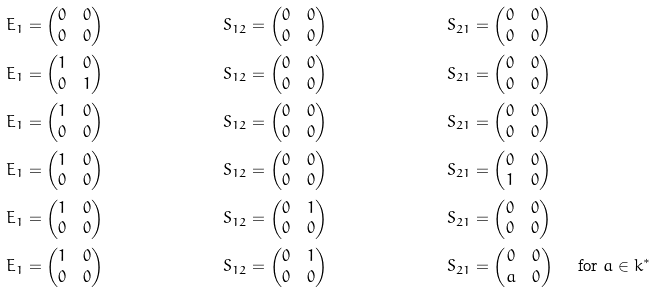<formula> <loc_0><loc_0><loc_500><loc_500>E _ { 1 } & = \left ( \begin{matrix} 0 & 0 \\ 0 & 0 \end{matrix} \right ) & S _ { 1 2 } & = \left ( \begin{matrix} 0 & 0 \\ 0 & 0 \end{matrix} \right ) & S _ { 2 1 } & = \left ( \begin{matrix} 0 & 0 \\ 0 & 0 \end{matrix} \right ) \\ E _ { 1 } & = \left ( \begin{matrix} 1 & 0 \\ 0 & 1 \end{matrix} \right ) & S _ { 1 2 } & = \left ( \begin{matrix} 0 & 0 \\ 0 & 0 \end{matrix} \right ) & S _ { 2 1 } & = \left ( \begin{matrix} 0 & 0 \\ 0 & 0 \end{matrix} \right ) \\ E _ { 1 } & = \left ( \begin{matrix} 1 & 0 \\ 0 & 0 \end{matrix} \right ) & S _ { 1 2 } & = \left ( \begin{matrix} 0 & 0 \\ 0 & 0 \end{matrix} \right ) & S _ { 2 1 } & = \left ( \begin{matrix} 0 & 0 \\ 0 & 0 \end{matrix} \right ) \\ E _ { 1 } & = \left ( \begin{matrix} 1 & 0 \\ 0 & 0 \end{matrix} \right ) & S _ { 1 2 } & = \left ( \begin{matrix} 0 & 0 \\ 0 & 0 \end{matrix} \right ) & S _ { 2 1 } & = \left ( \begin{matrix} 0 & 0 \\ 1 & 0 \end{matrix} \right ) \\ E _ { 1 } & = \left ( \begin{matrix} 1 & 0 \\ 0 & 0 \end{matrix} \right ) & S _ { 1 2 } & = \left ( \begin{matrix} 0 & 1 \\ 0 & 0 \end{matrix} \right ) & S _ { 2 1 } & = \left ( \begin{matrix} 0 & 0 \\ 0 & 0 \end{matrix} \right ) \\ E _ { 1 } & = \left ( \begin{matrix} 1 & 0 \\ 0 & 0 \end{matrix} \right ) & S _ { 1 2 } & = \left ( \begin{matrix} 0 & 1 \\ 0 & 0 \end{matrix} \right ) & S _ { 2 1 } & = \left ( \begin{matrix} 0 & 0 \\ a & 0 \end{matrix} \right ) \quad \text { for } a \in k ^ { * }</formula> 